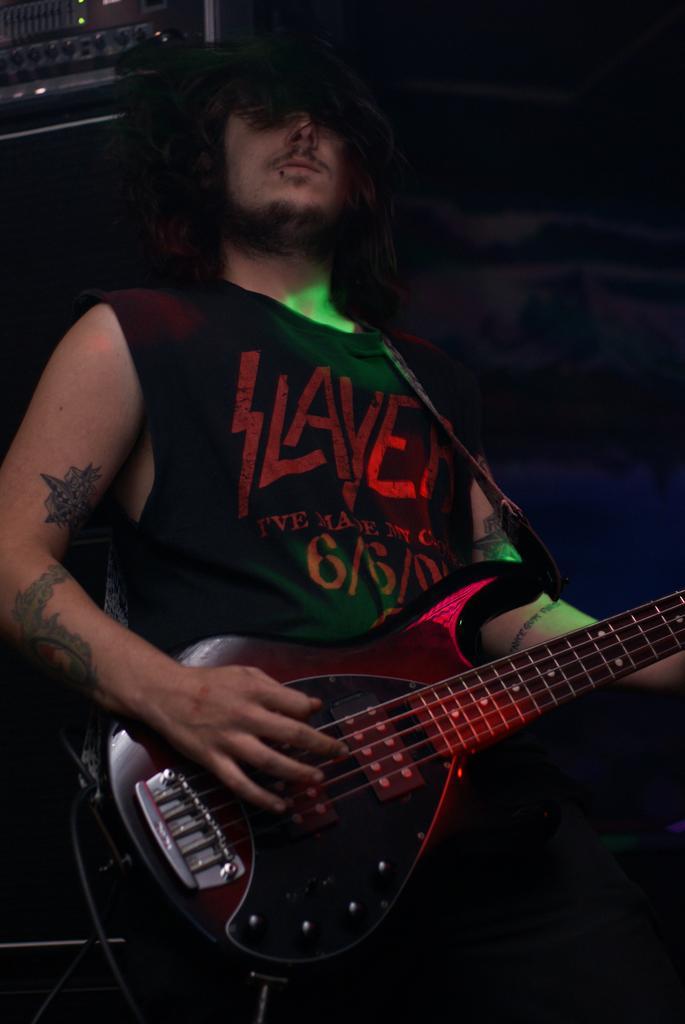Could you give a brief overview of what you see in this image? In this image I see a man who is standing and holding a guitar in his hand, I can also see some tattoos on his hands and he is wearing a tank top. In the background I see an equipment. 